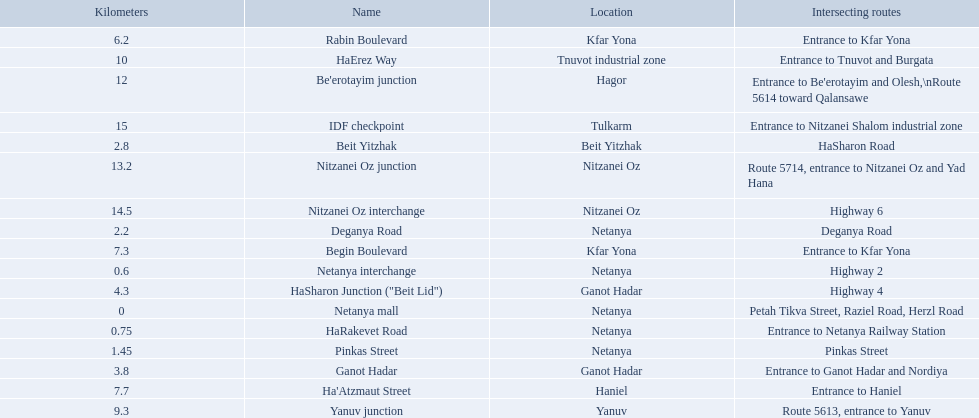What is the intersecting route of rabin boulevard? Entrance to Kfar Yona. Which portion has this intersecting route? Begin Boulevard. 